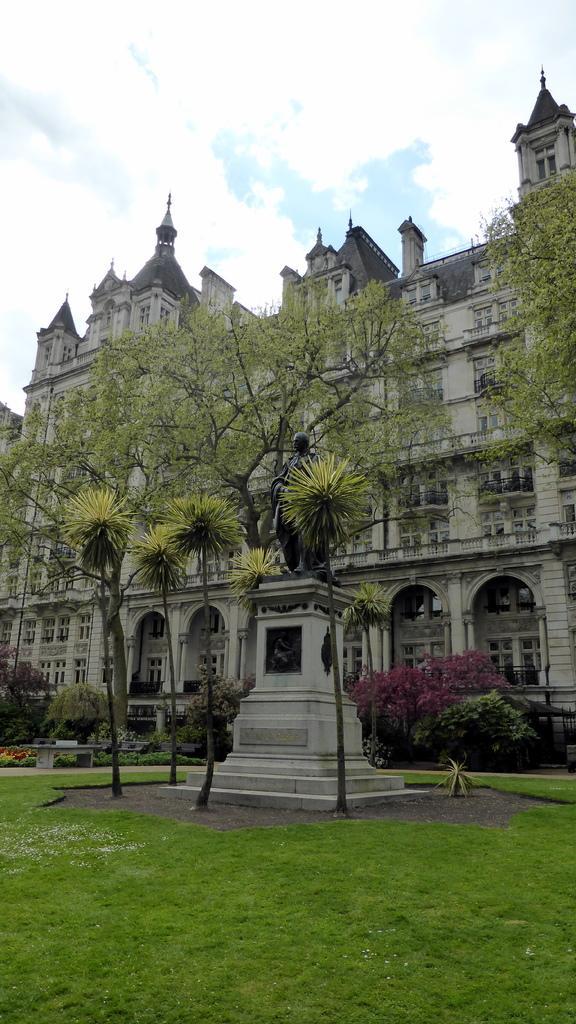In one or two sentences, can you explain what this image depicts? In this image in the front there's grass on the ground. In the background there are trees and there is a castle and the sky is cloudy. 